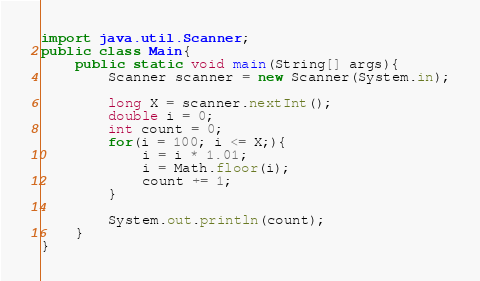<code> <loc_0><loc_0><loc_500><loc_500><_Java_>import java.util.Scanner;
public class Main{
    public static void main(String[] args){
        Scanner scanner = new Scanner(System.in);
        
        long X = scanner.nextInt();
        double i = 0;
        int count = 0;
        for(i = 100; i <= X;){
            i = i * 1.01;
            i = Math.floor(i);
            count += 1;
        }

        System.out.println(count);
    }
}</code> 